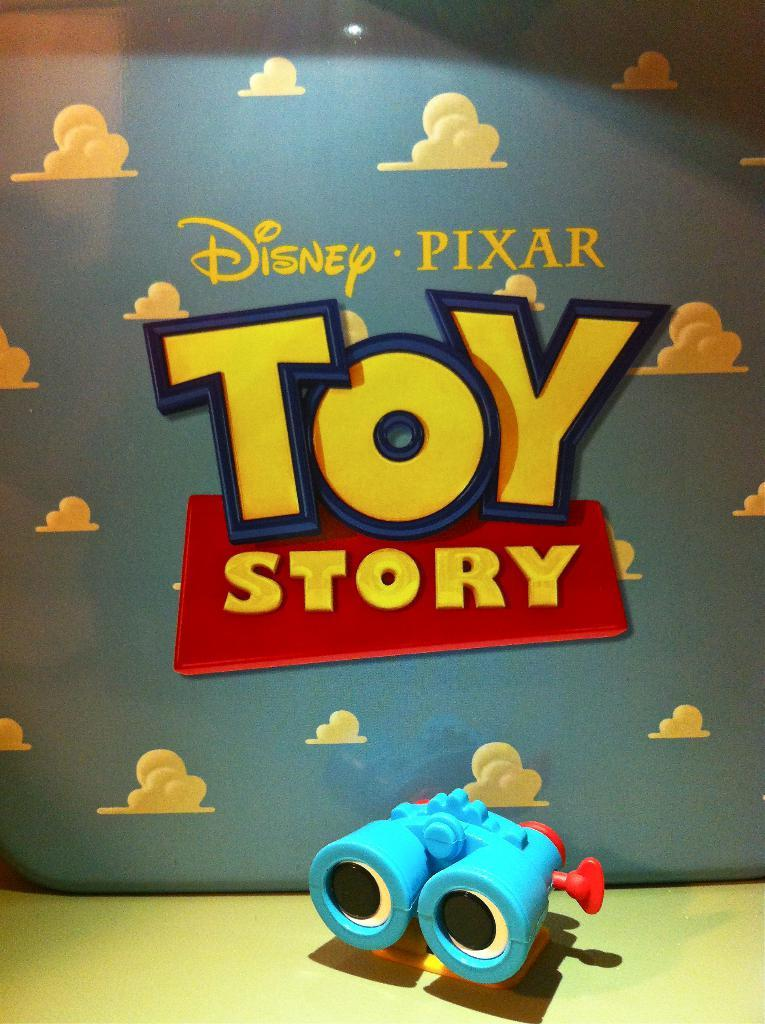Provide a one-sentence caption for the provided image. Poster for the movie Toy Story by Disney. 